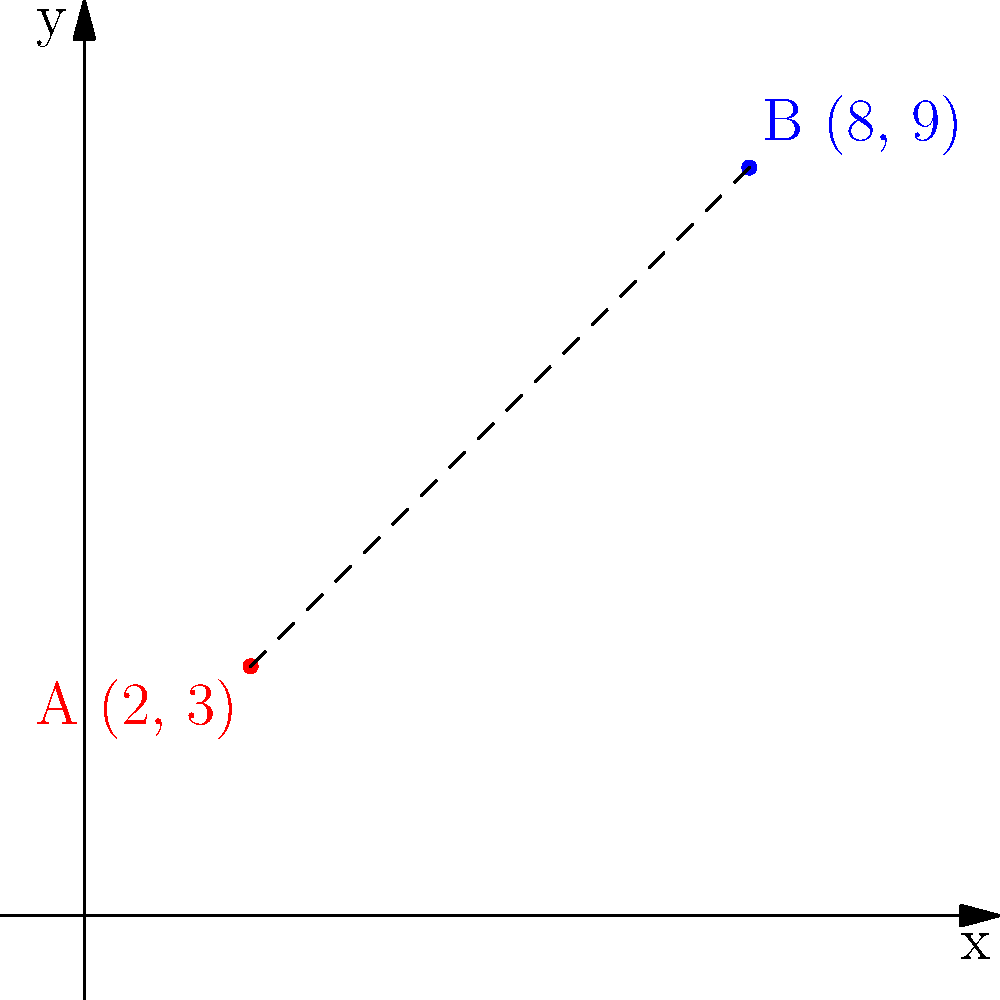Two community centers in Minneapolis are represented as points on a coordinate plane. Center A is located at (2, 3) and Center B is at (8, 9). What is the distance between these two community centers? To find the distance between two points on a coordinate plane, we can use the distance formula:

$$ d = \sqrt{(x_2 - x_1)^2 + (y_2 - y_1)^2} $$

Where $(x_1, y_1)$ are the coordinates of the first point and $(x_2, y_2)$ are the coordinates of the second point.

Let's plug in our values:
- Point A: $(x_1, y_1) = (2, 3)$
- Point B: $(x_2, y_2) = (8, 9)$

Now, let's calculate:

1) First, find the differences:
   $x_2 - x_1 = 8 - 2 = 6$
   $y_2 - y_1 = 9 - 3 = 6$

2) Square these differences:
   $(x_2 - x_1)^2 = 6^2 = 36$
   $(y_2 - y_1)^2 = 6^2 = 36$

3) Add these squared differences:
   $36 + 36 = 72$

4) Take the square root of the sum:
   $d = \sqrt{72} = 6\sqrt{2} \approx 8.49$

Therefore, the distance between the two community centers is $6\sqrt{2}$ units, or approximately 8.49 units.
Answer: $6\sqrt{2}$ units 